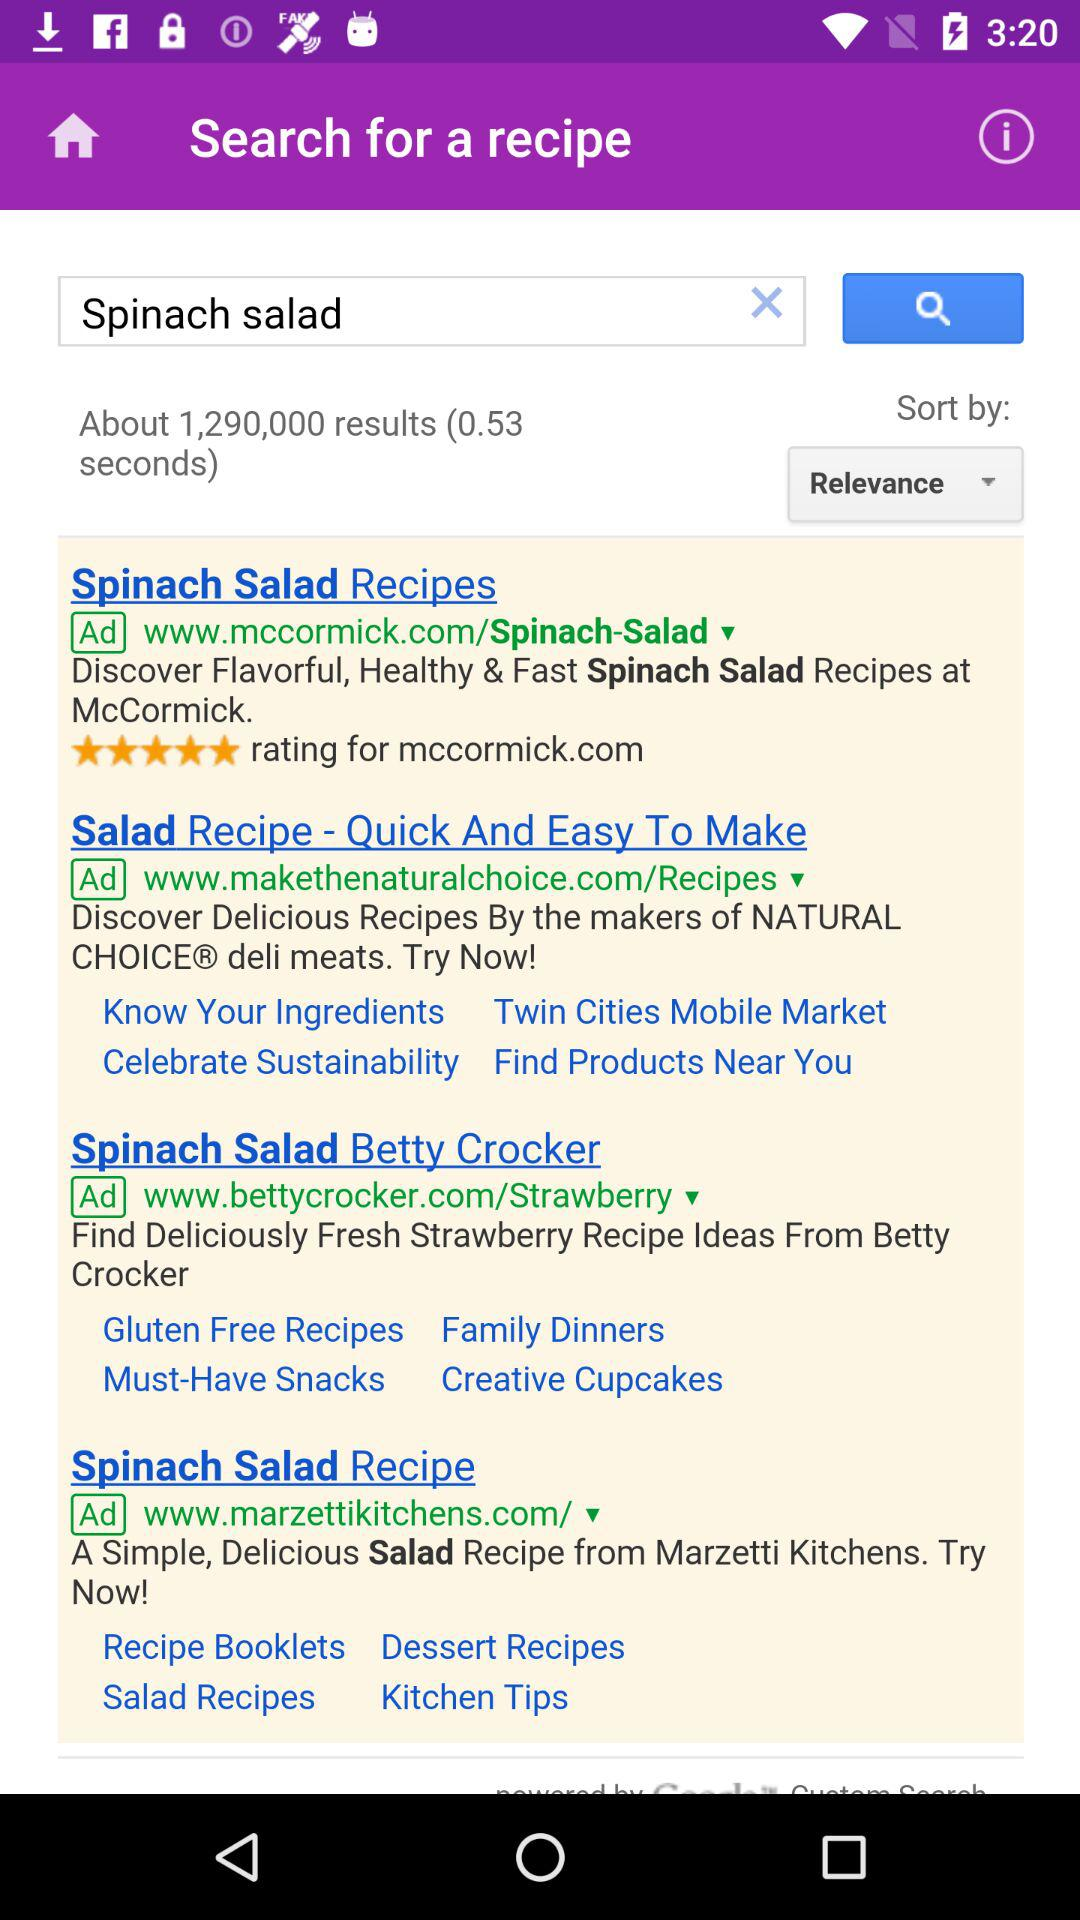How much time was taken to gather the results? The time taken to gather the results is 0.53 seconds. 